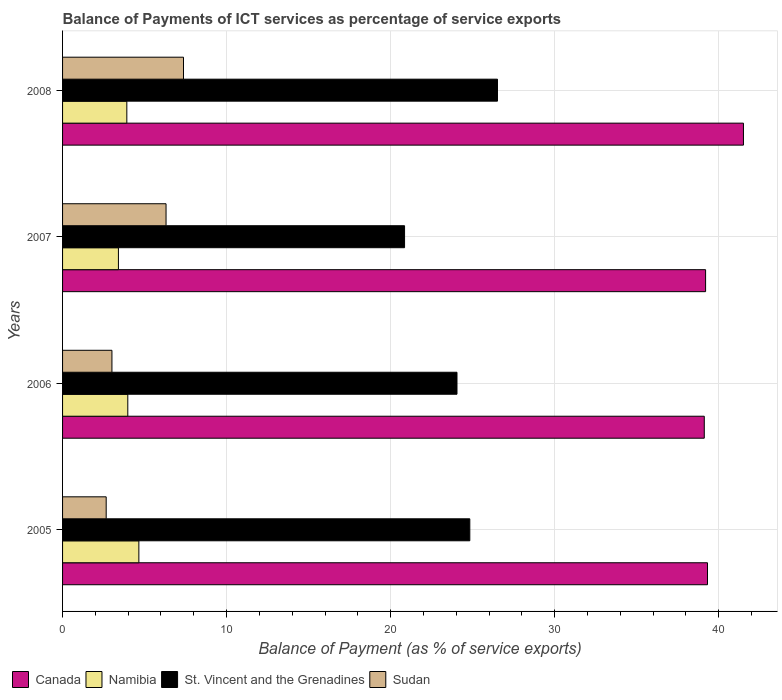Are the number of bars per tick equal to the number of legend labels?
Give a very brief answer. Yes. How many bars are there on the 1st tick from the top?
Offer a very short reply. 4. What is the label of the 4th group of bars from the top?
Your answer should be very brief. 2005. What is the balance of payments of ICT services in St. Vincent and the Grenadines in 2007?
Provide a succinct answer. 20.85. Across all years, what is the maximum balance of payments of ICT services in Canada?
Your answer should be very brief. 41.51. Across all years, what is the minimum balance of payments of ICT services in Sudan?
Give a very brief answer. 2.66. In which year was the balance of payments of ICT services in Canada maximum?
Give a very brief answer. 2008. What is the total balance of payments of ICT services in Sudan in the graph?
Offer a very short reply. 19.35. What is the difference between the balance of payments of ICT services in Sudan in 2005 and that in 2008?
Ensure brevity in your answer.  -4.71. What is the difference between the balance of payments of ICT services in Sudan in 2006 and the balance of payments of ICT services in St. Vincent and the Grenadines in 2008?
Give a very brief answer. -23.51. What is the average balance of payments of ICT services in Namibia per year?
Ensure brevity in your answer.  3.99. In the year 2008, what is the difference between the balance of payments of ICT services in Sudan and balance of payments of ICT services in Canada?
Keep it short and to the point. -34.14. In how many years, is the balance of payments of ICT services in Namibia greater than 36 %?
Your answer should be compact. 0. What is the ratio of the balance of payments of ICT services in Namibia in 2006 to that in 2007?
Offer a terse response. 1.17. Is the balance of payments of ICT services in Sudan in 2006 less than that in 2007?
Offer a very short reply. Yes. What is the difference between the highest and the second highest balance of payments of ICT services in St. Vincent and the Grenadines?
Provide a succinct answer. 1.69. What is the difference between the highest and the lowest balance of payments of ICT services in Canada?
Give a very brief answer. 2.39. Is the sum of the balance of payments of ICT services in Namibia in 2005 and 2006 greater than the maximum balance of payments of ICT services in Sudan across all years?
Your answer should be very brief. Yes. Is it the case that in every year, the sum of the balance of payments of ICT services in Canada and balance of payments of ICT services in St. Vincent and the Grenadines is greater than the sum of balance of payments of ICT services in Sudan and balance of payments of ICT services in Namibia?
Offer a very short reply. No. What does the 2nd bar from the bottom in 2007 represents?
Provide a short and direct response. Namibia. Is it the case that in every year, the sum of the balance of payments of ICT services in Canada and balance of payments of ICT services in St. Vincent and the Grenadines is greater than the balance of payments of ICT services in Namibia?
Your answer should be very brief. Yes. Are all the bars in the graph horizontal?
Offer a terse response. Yes. How many years are there in the graph?
Your response must be concise. 4. What is the difference between two consecutive major ticks on the X-axis?
Keep it short and to the point. 10. Are the values on the major ticks of X-axis written in scientific E-notation?
Provide a succinct answer. No. Does the graph contain any zero values?
Offer a very short reply. No. Where does the legend appear in the graph?
Offer a terse response. Bottom left. What is the title of the graph?
Your answer should be very brief. Balance of Payments of ICT services as percentage of service exports. Does "Barbados" appear as one of the legend labels in the graph?
Keep it short and to the point. No. What is the label or title of the X-axis?
Give a very brief answer. Balance of Payment (as % of service exports). What is the Balance of Payment (as % of service exports) of Canada in 2005?
Make the answer very short. 39.32. What is the Balance of Payment (as % of service exports) in Namibia in 2005?
Your response must be concise. 4.65. What is the Balance of Payment (as % of service exports) of St. Vincent and the Grenadines in 2005?
Offer a very short reply. 24.83. What is the Balance of Payment (as % of service exports) in Sudan in 2005?
Make the answer very short. 2.66. What is the Balance of Payment (as % of service exports) of Canada in 2006?
Keep it short and to the point. 39.12. What is the Balance of Payment (as % of service exports) in Namibia in 2006?
Your answer should be very brief. 3.98. What is the Balance of Payment (as % of service exports) of St. Vincent and the Grenadines in 2006?
Ensure brevity in your answer.  24.05. What is the Balance of Payment (as % of service exports) of Sudan in 2006?
Make the answer very short. 3.01. What is the Balance of Payment (as % of service exports) in Canada in 2007?
Offer a very short reply. 39.2. What is the Balance of Payment (as % of service exports) of Namibia in 2007?
Your answer should be compact. 3.41. What is the Balance of Payment (as % of service exports) in St. Vincent and the Grenadines in 2007?
Your answer should be very brief. 20.85. What is the Balance of Payment (as % of service exports) in Sudan in 2007?
Keep it short and to the point. 6.31. What is the Balance of Payment (as % of service exports) in Canada in 2008?
Your answer should be compact. 41.51. What is the Balance of Payment (as % of service exports) of Namibia in 2008?
Keep it short and to the point. 3.92. What is the Balance of Payment (as % of service exports) in St. Vincent and the Grenadines in 2008?
Ensure brevity in your answer.  26.52. What is the Balance of Payment (as % of service exports) in Sudan in 2008?
Offer a terse response. 7.37. Across all years, what is the maximum Balance of Payment (as % of service exports) of Canada?
Make the answer very short. 41.51. Across all years, what is the maximum Balance of Payment (as % of service exports) of Namibia?
Offer a terse response. 4.65. Across all years, what is the maximum Balance of Payment (as % of service exports) in St. Vincent and the Grenadines?
Make the answer very short. 26.52. Across all years, what is the maximum Balance of Payment (as % of service exports) of Sudan?
Provide a succinct answer. 7.37. Across all years, what is the minimum Balance of Payment (as % of service exports) in Canada?
Ensure brevity in your answer.  39.12. Across all years, what is the minimum Balance of Payment (as % of service exports) of Namibia?
Offer a terse response. 3.41. Across all years, what is the minimum Balance of Payment (as % of service exports) in St. Vincent and the Grenadines?
Provide a succinct answer. 20.85. Across all years, what is the minimum Balance of Payment (as % of service exports) in Sudan?
Provide a succinct answer. 2.66. What is the total Balance of Payment (as % of service exports) in Canada in the graph?
Make the answer very short. 159.16. What is the total Balance of Payment (as % of service exports) of Namibia in the graph?
Your answer should be very brief. 15.95. What is the total Balance of Payment (as % of service exports) in St. Vincent and the Grenadines in the graph?
Your answer should be very brief. 96.24. What is the total Balance of Payment (as % of service exports) of Sudan in the graph?
Give a very brief answer. 19.35. What is the difference between the Balance of Payment (as % of service exports) in Canada in 2005 and that in 2006?
Make the answer very short. 0.2. What is the difference between the Balance of Payment (as % of service exports) of Namibia in 2005 and that in 2006?
Offer a very short reply. 0.67. What is the difference between the Balance of Payment (as % of service exports) of St. Vincent and the Grenadines in 2005 and that in 2006?
Offer a very short reply. 0.78. What is the difference between the Balance of Payment (as % of service exports) of Sudan in 2005 and that in 2006?
Keep it short and to the point. -0.35. What is the difference between the Balance of Payment (as % of service exports) in Canada in 2005 and that in 2007?
Provide a short and direct response. 0.12. What is the difference between the Balance of Payment (as % of service exports) of Namibia in 2005 and that in 2007?
Offer a terse response. 1.25. What is the difference between the Balance of Payment (as % of service exports) in St. Vincent and the Grenadines in 2005 and that in 2007?
Keep it short and to the point. 3.98. What is the difference between the Balance of Payment (as % of service exports) in Sudan in 2005 and that in 2007?
Ensure brevity in your answer.  -3.65. What is the difference between the Balance of Payment (as % of service exports) of Canada in 2005 and that in 2008?
Give a very brief answer. -2.19. What is the difference between the Balance of Payment (as % of service exports) of Namibia in 2005 and that in 2008?
Your response must be concise. 0.73. What is the difference between the Balance of Payment (as % of service exports) of St. Vincent and the Grenadines in 2005 and that in 2008?
Your answer should be very brief. -1.69. What is the difference between the Balance of Payment (as % of service exports) of Sudan in 2005 and that in 2008?
Keep it short and to the point. -4.71. What is the difference between the Balance of Payment (as % of service exports) of Canada in 2006 and that in 2007?
Keep it short and to the point. -0.08. What is the difference between the Balance of Payment (as % of service exports) in Namibia in 2006 and that in 2007?
Provide a succinct answer. 0.57. What is the difference between the Balance of Payment (as % of service exports) of St. Vincent and the Grenadines in 2006 and that in 2007?
Provide a succinct answer. 3.2. What is the difference between the Balance of Payment (as % of service exports) in Sudan in 2006 and that in 2007?
Offer a very short reply. -3.3. What is the difference between the Balance of Payment (as % of service exports) in Canada in 2006 and that in 2008?
Provide a succinct answer. -2.39. What is the difference between the Balance of Payment (as % of service exports) in Namibia in 2006 and that in 2008?
Offer a terse response. 0.06. What is the difference between the Balance of Payment (as % of service exports) of St. Vincent and the Grenadines in 2006 and that in 2008?
Your answer should be very brief. -2.47. What is the difference between the Balance of Payment (as % of service exports) in Sudan in 2006 and that in 2008?
Your answer should be very brief. -4.36. What is the difference between the Balance of Payment (as % of service exports) of Canada in 2007 and that in 2008?
Ensure brevity in your answer.  -2.31. What is the difference between the Balance of Payment (as % of service exports) of Namibia in 2007 and that in 2008?
Offer a very short reply. -0.51. What is the difference between the Balance of Payment (as % of service exports) in St. Vincent and the Grenadines in 2007 and that in 2008?
Ensure brevity in your answer.  -5.66. What is the difference between the Balance of Payment (as % of service exports) in Sudan in 2007 and that in 2008?
Offer a terse response. -1.06. What is the difference between the Balance of Payment (as % of service exports) in Canada in 2005 and the Balance of Payment (as % of service exports) in Namibia in 2006?
Give a very brief answer. 35.34. What is the difference between the Balance of Payment (as % of service exports) in Canada in 2005 and the Balance of Payment (as % of service exports) in St. Vincent and the Grenadines in 2006?
Ensure brevity in your answer.  15.27. What is the difference between the Balance of Payment (as % of service exports) in Canada in 2005 and the Balance of Payment (as % of service exports) in Sudan in 2006?
Your response must be concise. 36.31. What is the difference between the Balance of Payment (as % of service exports) in Namibia in 2005 and the Balance of Payment (as % of service exports) in St. Vincent and the Grenadines in 2006?
Your answer should be compact. -19.4. What is the difference between the Balance of Payment (as % of service exports) in Namibia in 2005 and the Balance of Payment (as % of service exports) in Sudan in 2006?
Your answer should be very brief. 1.64. What is the difference between the Balance of Payment (as % of service exports) of St. Vincent and the Grenadines in 2005 and the Balance of Payment (as % of service exports) of Sudan in 2006?
Provide a short and direct response. 21.82. What is the difference between the Balance of Payment (as % of service exports) of Canada in 2005 and the Balance of Payment (as % of service exports) of Namibia in 2007?
Offer a very short reply. 35.91. What is the difference between the Balance of Payment (as % of service exports) in Canada in 2005 and the Balance of Payment (as % of service exports) in St. Vincent and the Grenadines in 2007?
Your answer should be compact. 18.47. What is the difference between the Balance of Payment (as % of service exports) in Canada in 2005 and the Balance of Payment (as % of service exports) in Sudan in 2007?
Ensure brevity in your answer.  33.01. What is the difference between the Balance of Payment (as % of service exports) in Namibia in 2005 and the Balance of Payment (as % of service exports) in St. Vincent and the Grenadines in 2007?
Offer a terse response. -16.2. What is the difference between the Balance of Payment (as % of service exports) in Namibia in 2005 and the Balance of Payment (as % of service exports) in Sudan in 2007?
Your answer should be very brief. -1.66. What is the difference between the Balance of Payment (as % of service exports) in St. Vincent and the Grenadines in 2005 and the Balance of Payment (as % of service exports) in Sudan in 2007?
Ensure brevity in your answer.  18.52. What is the difference between the Balance of Payment (as % of service exports) in Canada in 2005 and the Balance of Payment (as % of service exports) in Namibia in 2008?
Offer a very short reply. 35.4. What is the difference between the Balance of Payment (as % of service exports) of Canada in 2005 and the Balance of Payment (as % of service exports) of St. Vincent and the Grenadines in 2008?
Ensure brevity in your answer.  12.8. What is the difference between the Balance of Payment (as % of service exports) of Canada in 2005 and the Balance of Payment (as % of service exports) of Sudan in 2008?
Ensure brevity in your answer.  31.95. What is the difference between the Balance of Payment (as % of service exports) in Namibia in 2005 and the Balance of Payment (as % of service exports) in St. Vincent and the Grenadines in 2008?
Your answer should be very brief. -21.86. What is the difference between the Balance of Payment (as % of service exports) of Namibia in 2005 and the Balance of Payment (as % of service exports) of Sudan in 2008?
Provide a short and direct response. -2.72. What is the difference between the Balance of Payment (as % of service exports) in St. Vincent and the Grenadines in 2005 and the Balance of Payment (as % of service exports) in Sudan in 2008?
Your answer should be very brief. 17.46. What is the difference between the Balance of Payment (as % of service exports) of Canada in 2006 and the Balance of Payment (as % of service exports) of Namibia in 2007?
Keep it short and to the point. 35.72. What is the difference between the Balance of Payment (as % of service exports) in Canada in 2006 and the Balance of Payment (as % of service exports) in St. Vincent and the Grenadines in 2007?
Give a very brief answer. 18.27. What is the difference between the Balance of Payment (as % of service exports) in Canada in 2006 and the Balance of Payment (as % of service exports) in Sudan in 2007?
Give a very brief answer. 32.81. What is the difference between the Balance of Payment (as % of service exports) of Namibia in 2006 and the Balance of Payment (as % of service exports) of St. Vincent and the Grenadines in 2007?
Offer a terse response. -16.87. What is the difference between the Balance of Payment (as % of service exports) of Namibia in 2006 and the Balance of Payment (as % of service exports) of Sudan in 2007?
Make the answer very short. -2.33. What is the difference between the Balance of Payment (as % of service exports) in St. Vincent and the Grenadines in 2006 and the Balance of Payment (as % of service exports) in Sudan in 2007?
Offer a very short reply. 17.74. What is the difference between the Balance of Payment (as % of service exports) of Canada in 2006 and the Balance of Payment (as % of service exports) of Namibia in 2008?
Your answer should be very brief. 35.2. What is the difference between the Balance of Payment (as % of service exports) in Canada in 2006 and the Balance of Payment (as % of service exports) in St. Vincent and the Grenadines in 2008?
Offer a very short reply. 12.61. What is the difference between the Balance of Payment (as % of service exports) in Canada in 2006 and the Balance of Payment (as % of service exports) in Sudan in 2008?
Make the answer very short. 31.75. What is the difference between the Balance of Payment (as % of service exports) in Namibia in 2006 and the Balance of Payment (as % of service exports) in St. Vincent and the Grenadines in 2008?
Ensure brevity in your answer.  -22.54. What is the difference between the Balance of Payment (as % of service exports) in Namibia in 2006 and the Balance of Payment (as % of service exports) in Sudan in 2008?
Provide a short and direct response. -3.4. What is the difference between the Balance of Payment (as % of service exports) in St. Vincent and the Grenadines in 2006 and the Balance of Payment (as % of service exports) in Sudan in 2008?
Your answer should be very brief. 16.67. What is the difference between the Balance of Payment (as % of service exports) of Canada in 2007 and the Balance of Payment (as % of service exports) of Namibia in 2008?
Make the answer very short. 35.29. What is the difference between the Balance of Payment (as % of service exports) in Canada in 2007 and the Balance of Payment (as % of service exports) in St. Vincent and the Grenadines in 2008?
Your answer should be compact. 12.69. What is the difference between the Balance of Payment (as % of service exports) in Canada in 2007 and the Balance of Payment (as % of service exports) in Sudan in 2008?
Provide a succinct answer. 31.83. What is the difference between the Balance of Payment (as % of service exports) of Namibia in 2007 and the Balance of Payment (as % of service exports) of St. Vincent and the Grenadines in 2008?
Your response must be concise. -23.11. What is the difference between the Balance of Payment (as % of service exports) in Namibia in 2007 and the Balance of Payment (as % of service exports) in Sudan in 2008?
Your answer should be compact. -3.97. What is the difference between the Balance of Payment (as % of service exports) of St. Vincent and the Grenadines in 2007 and the Balance of Payment (as % of service exports) of Sudan in 2008?
Give a very brief answer. 13.48. What is the average Balance of Payment (as % of service exports) in Canada per year?
Ensure brevity in your answer.  39.79. What is the average Balance of Payment (as % of service exports) of Namibia per year?
Ensure brevity in your answer.  3.99. What is the average Balance of Payment (as % of service exports) in St. Vincent and the Grenadines per year?
Give a very brief answer. 24.06. What is the average Balance of Payment (as % of service exports) in Sudan per year?
Keep it short and to the point. 4.84. In the year 2005, what is the difference between the Balance of Payment (as % of service exports) in Canada and Balance of Payment (as % of service exports) in Namibia?
Your answer should be very brief. 34.67. In the year 2005, what is the difference between the Balance of Payment (as % of service exports) in Canada and Balance of Payment (as % of service exports) in St. Vincent and the Grenadines?
Provide a short and direct response. 14.49. In the year 2005, what is the difference between the Balance of Payment (as % of service exports) in Canada and Balance of Payment (as % of service exports) in Sudan?
Offer a very short reply. 36.66. In the year 2005, what is the difference between the Balance of Payment (as % of service exports) in Namibia and Balance of Payment (as % of service exports) in St. Vincent and the Grenadines?
Your answer should be very brief. -20.18. In the year 2005, what is the difference between the Balance of Payment (as % of service exports) in Namibia and Balance of Payment (as % of service exports) in Sudan?
Ensure brevity in your answer.  1.99. In the year 2005, what is the difference between the Balance of Payment (as % of service exports) of St. Vincent and the Grenadines and Balance of Payment (as % of service exports) of Sudan?
Your response must be concise. 22.17. In the year 2006, what is the difference between the Balance of Payment (as % of service exports) in Canada and Balance of Payment (as % of service exports) in Namibia?
Provide a succinct answer. 35.15. In the year 2006, what is the difference between the Balance of Payment (as % of service exports) of Canada and Balance of Payment (as % of service exports) of St. Vincent and the Grenadines?
Provide a short and direct response. 15.08. In the year 2006, what is the difference between the Balance of Payment (as % of service exports) of Canada and Balance of Payment (as % of service exports) of Sudan?
Keep it short and to the point. 36.11. In the year 2006, what is the difference between the Balance of Payment (as % of service exports) of Namibia and Balance of Payment (as % of service exports) of St. Vincent and the Grenadines?
Keep it short and to the point. -20.07. In the year 2006, what is the difference between the Balance of Payment (as % of service exports) in Namibia and Balance of Payment (as % of service exports) in Sudan?
Offer a very short reply. 0.97. In the year 2006, what is the difference between the Balance of Payment (as % of service exports) in St. Vincent and the Grenadines and Balance of Payment (as % of service exports) in Sudan?
Your answer should be very brief. 21.04. In the year 2007, what is the difference between the Balance of Payment (as % of service exports) of Canada and Balance of Payment (as % of service exports) of Namibia?
Your answer should be very brief. 35.8. In the year 2007, what is the difference between the Balance of Payment (as % of service exports) of Canada and Balance of Payment (as % of service exports) of St. Vincent and the Grenadines?
Your response must be concise. 18.35. In the year 2007, what is the difference between the Balance of Payment (as % of service exports) in Canada and Balance of Payment (as % of service exports) in Sudan?
Give a very brief answer. 32.89. In the year 2007, what is the difference between the Balance of Payment (as % of service exports) of Namibia and Balance of Payment (as % of service exports) of St. Vincent and the Grenadines?
Offer a terse response. -17.45. In the year 2007, what is the difference between the Balance of Payment (as % of service exports) of Namibia and Balance of Payment (as % of service exports) of Sudan?
Provide a succinct answer. -2.9. In the year 2007, what is the difference between the Balance of Payment (as % of service exports) in St. Vincent and the Grenadines and Balance of Payment (as % of service exports) in Sudan?
Provide a short and direct response. 14.54. In the year 2008, what is the difference between the Balance of Payment (as % of service exports) of Canada and Balance of Payment (as % of service exports) of Namibia?
Keep it short and to the point. 37.59. In the year 2008, what is the difference between the Balance of Payment (as % of service exports) of Canada and Balance of Payment (as % of service exports) of St. Vincent and the Grenadines?
Provide a succinct answer. 15. In the year 2008, what is the difference between the Balance of Payment (as % of service exports) of Canada and Balance of Payment (as % of service exports) of Sudan?
Your response must be concise. 34.14. In the year 2008, what is the difference between the Balance of Payment (as % of service exports) of Namibia and Balance of Payment (as % of service exports) of St. Vincent and the Grenadines?
Your answer should be very brief. -22.6. In the year 2008, what is the difference between the Balance of Payment (as % of service exports) in Namibia and Balance of Payment (as % of service exports) in Sudan?
Provide a short and direct response. -3.45. In the year 2008, what is the difference between the Balance of Payment (as % of service exports) of St. Vincent and the Grenadines and Balance of Payment (as % of service exports) of Sudan?
Keep it short and to the point. 19.14. What is the ratio of the Balance of Payment (as % of service exports) of Canada in 2005 to that in 2006?
Your answer should be compact. 1. What is the ratio of the Balance of Payment (as % of service exports) in Namibia in 2005 to that in 2006?
Offer a terse response. 1.17. What is the ratio of the Balance of Payment (as % of service exports) of St. Vincent and the Grenadines in 2005 to that in 2006?
Your response must be concise. 1.03. What is the ratio of the Balance of Payment (as % of service exports) in Sudan in 2005 to that in 2006?
Provide a short and direct response. 0.88. What is the ratio of the Balance of Payment (as % of service exports) in Namibia in 2005 to that in 2007?
Your response must be concise. 1.37. What is the ratio of the Balance of Payment (as % of service exports) of St. Vincent and the Grenadines in 2005 to that in 2007?
Ensure brevity in your answer.  1.19. What is the ratio of the Balance of Payment (as % of service exports) in Sudan in 2005 to that in 2007?
Give a very brief answer. 0.42. What is the ratio of the Balance of Payment (as % of service exports) in Canada in 2005 to that in 2008?
Your response must be concise. 0.95. What is the ratio of the Balance of Payment (as % of service exports) of Namibia in 2005 to that in 2008?
Offer a very short reply. 1.19. What is the ratio of the Balance of Payment (as % of service exports) in St. Vincent and the Grenadines in 2005 to that in 2008?
Give a very brief answer. 0.94. What is the ratio of the Balance of Payment (as % of service exports) of Sudan in 2005 to that in 2008?
Your answer should be compact. 0.36. What is the ratio of the Balance of Payment (as % of service exports) in Canada in 2006 to that in 2007?
Your response must be concise. 1. What is the ratio of the Balance of Payment (as % of service exports) in Namibia in 2006 to that in 2007?
Your answer should be compact. 1.17. What is the ratio of the Balance of Payment (as % of service exports) in St. Vincent and the Grenadines in 2006 to that in 2007?
Your answer should be compact. 1.15. What is the ratio of the Balance of Payment (as % of service exports) in Sudan in 2006 to that in 2007?
Provide a short and direct response. 0.48. What is the ratio of the Balance of Payment (as % of service exports) in Canada in 2006 to that in 2008?
Keep it short and to the point. 0.94. What is the ratio of the Balance of Payment (as % of service exports) in Namibia in 2006 to that in 2008?
Provide a succinct answer. 1.01. What is the ratio of the Balance of Payment (as % of service exports) in St. Vincent and the Grenadines in 2006 to that in 2008?
Your answer should be compact. 0.91. What is the ratio of the Balance of Payment (as % of service exports) in Sudan in 2006 to that in 2008?
Provide a succinct answer. 0.41. What is the ratio of the Balance of Payment (as % of service exports) in Namibia in 2007 to that in 2008?
Offer a terse response. 0.87. What is the ratio of the Balance of Payment (as % of service exports) of St. Vincent and the Grenadines in 2007 to that in 2008?
Make the answer very short. 0.79. What is the ratio of the Balance of Payment (as % of service exports) in Sudan in 2007 to that in 2008?
Provide a short and direct response. 0.86. What is the difference between the highest and the second highest Balance of Payment (as % of service exports) of Canada?
Your answer should be compact. 2.19. What is the difference between the highest and the second highest Balance of Payment (as % of service exports) in Namibia?
Provide a short and direct response. 0.67. What is the difference between the highest and the second highest Balance of Payment (as % of service exports) of St. Vincent and the Grenadines?
Keep it short and to the point. 1.69. What is the difference between the highest and the second highest Balance of Payment (as % of service exports) of Sudan?
Provide a succinct answer. 1.06. What is the difference between the highest and the lowest Balance of Payment (as % of service exports) of Canada?
Provide a succinct answer. 2.39. What is the difference between the highest and the lowest Balance of Payment (as % of service exports) of Namibia?
Provide a succinct answer. 1.25. What is the difference between the highest and the lowest Balance of Payment (as % of service exports) of St. Vincent and the Grenadines?
Keep it short and to the point. 5.66. What is the difference between the highest and the lowest Balance of Payment (as % of service exports) in Sudan?
Give a very brief answer. 4.71. 